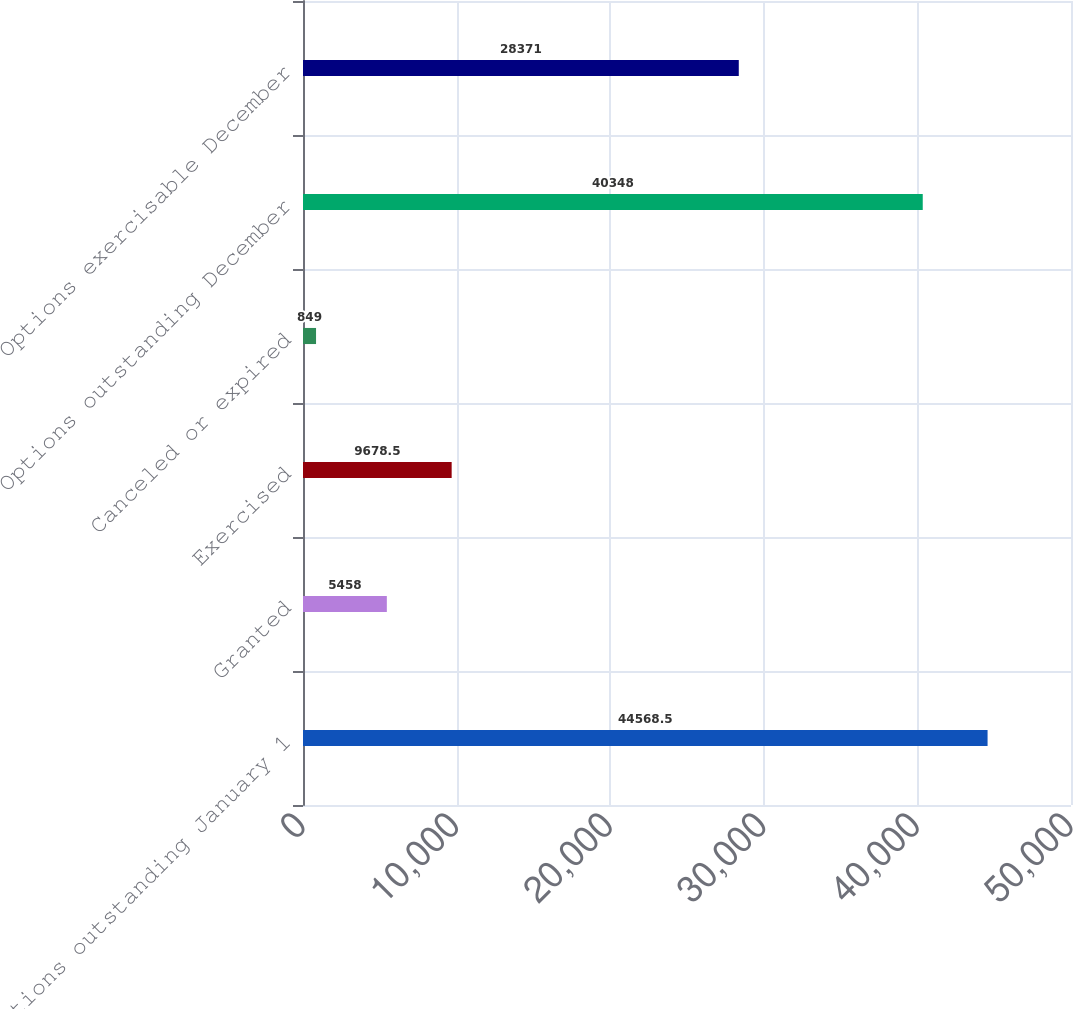<chart> <loc_0><loc_0><loc_500><loc_500><bar_chart><fcel>Options outstanding January 1<fcel>Granted<fcel>Exercised<fcel>Canceled or expired<fcel>Options outstanding December<fcel>Options exercisable December<nl><fcel>44568.5<fcel>5458<fcel>9678.5<fcel>849<fcel>40348<fcel>28371<nl></chart> 